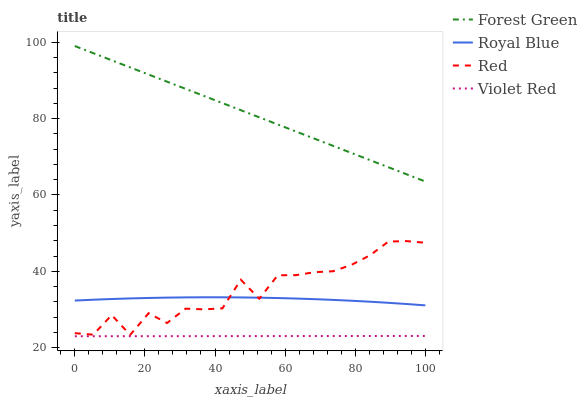Does Violet Red have the minimum area under the curve?
Answer yes or no. Yes. Does Forest Green have the maximum area under the curve?
Answer yes or no. Yes. Does Forest Green have the minimum area under the curve?
Answer yes or no. No. Does Violet Red have the maximum area under the curve?
Answer yes or no. No. Is Violet Red the smoothest?
Answer yes or no. Yes. Is Red the roughest?
Answer yes or no. Yes. Is Forest Green the smoothest?
Answer yes or no. No. Is Forest Green the roughest?
Answer yes or no. No. Does Violet Red have the lowest value?
Answer yes or no. Yes. Does Forest Green have the lowest value?
Answer yes or no. No. Does Forest Green have the highest value?
Answer yes or no. Yes. Does Violet Red have the highest value?
Answer yes or no. No. Is Royal Blue less than Forest Green?
Answer yes or no. Yes. Is Royal Blue greater than Violet Red?
Answer yes or no. Yes. Does Red intersect Royal Blue?
Answer yes or no. Yes. Is Red less than Royal Blue?
Answer yes or no. No. Is Red greater than Royal Blue?
Answer yes or no. No. Does Royal Blue intersect Forest Green?
Answer yes or no. No. 